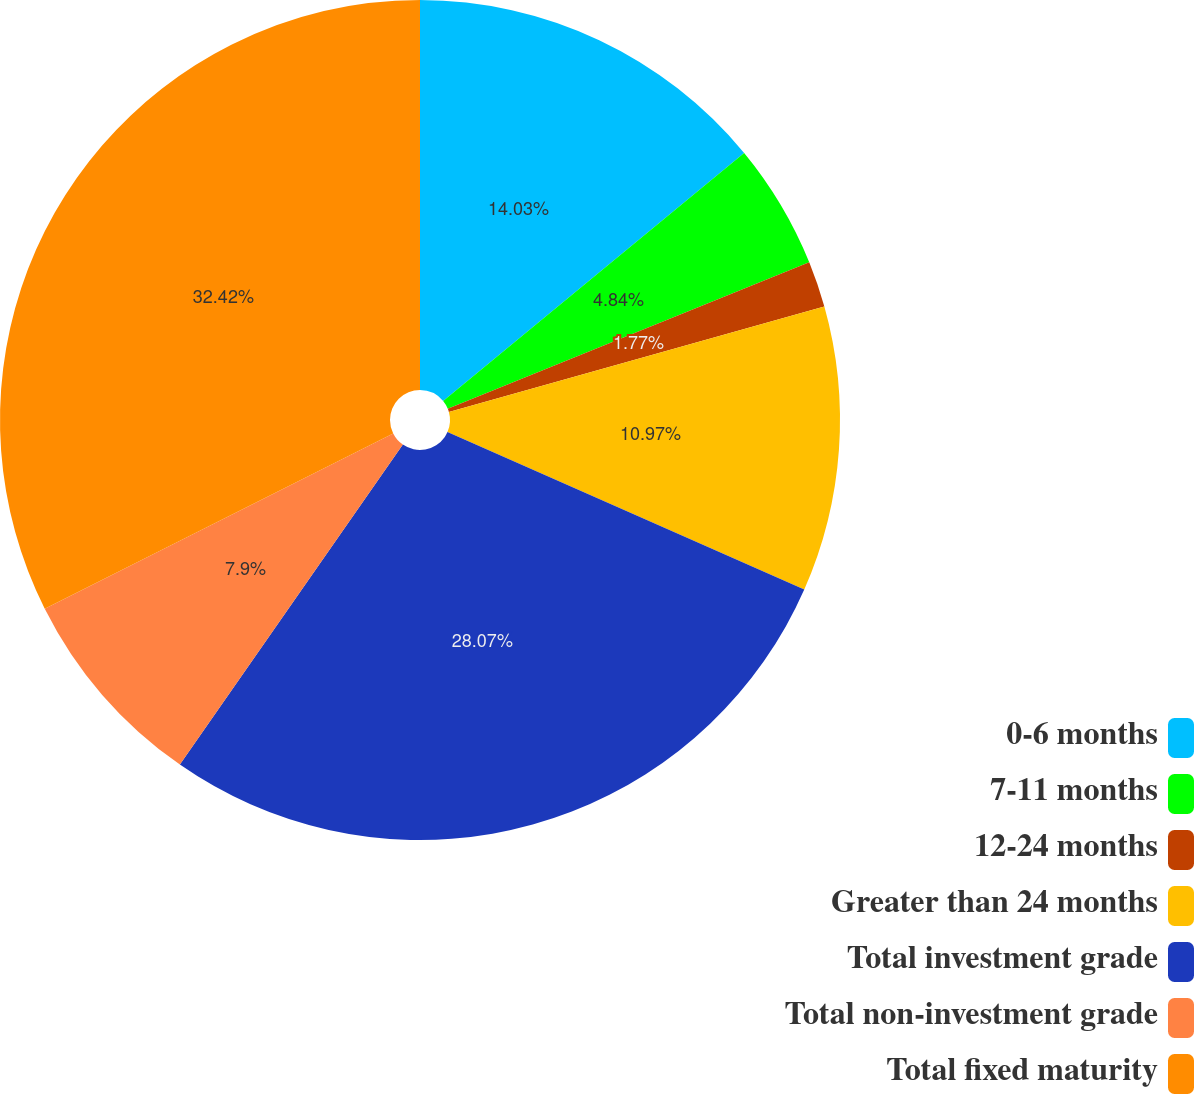Convert chart to OTSL. <chart><loc_0><loc_0><loc_500><loc_500><pie_chart><fcel>0-6 months<fcel>7-11 months<fcel>12-24 months<fcel>Greater than 24 months<fcel>Total investment grade<fcel>Total non-investment grade<fcel>Total fixed maturity<nl><fcel>14.03%<fcel>4.84%<fcel>1.77%<fcel>10.97%<fcel>28.07%<fcel>7.9%<fcel>32.41%<nl></chart> 